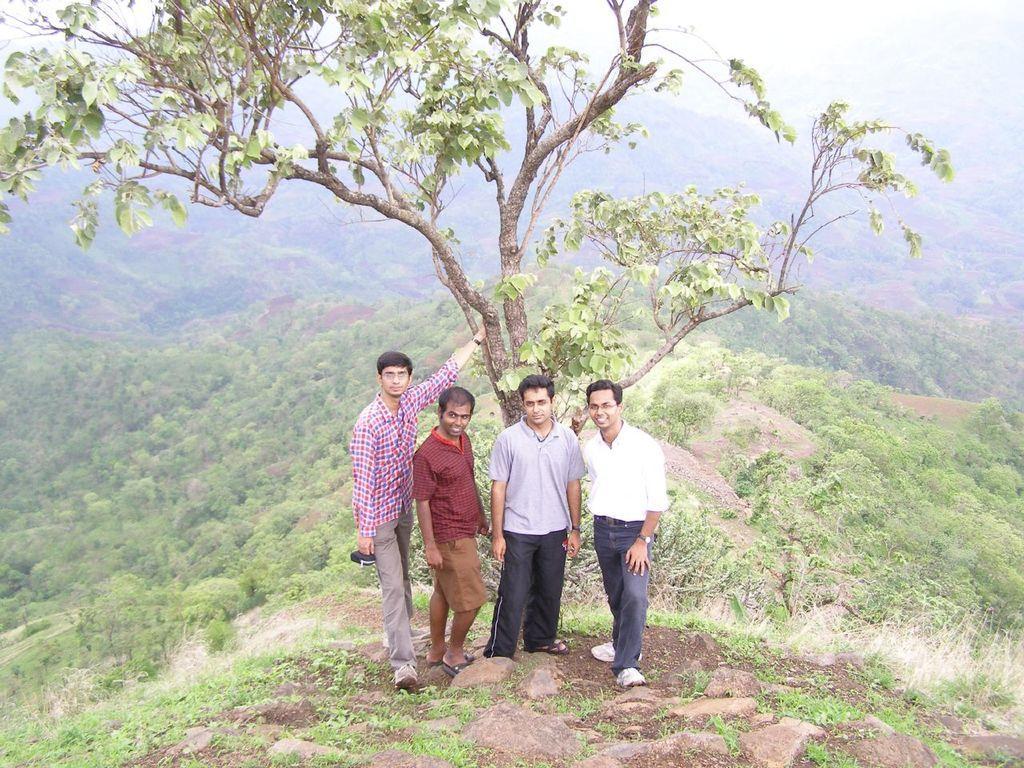Please provide a concise description of this image. The picture is captured in a hilly area. In the foreground of the picture there are four men standing, behind them there is a tree. In the foreground there are plants, stones and soil. In the background there are fields covered with trees and grass. 